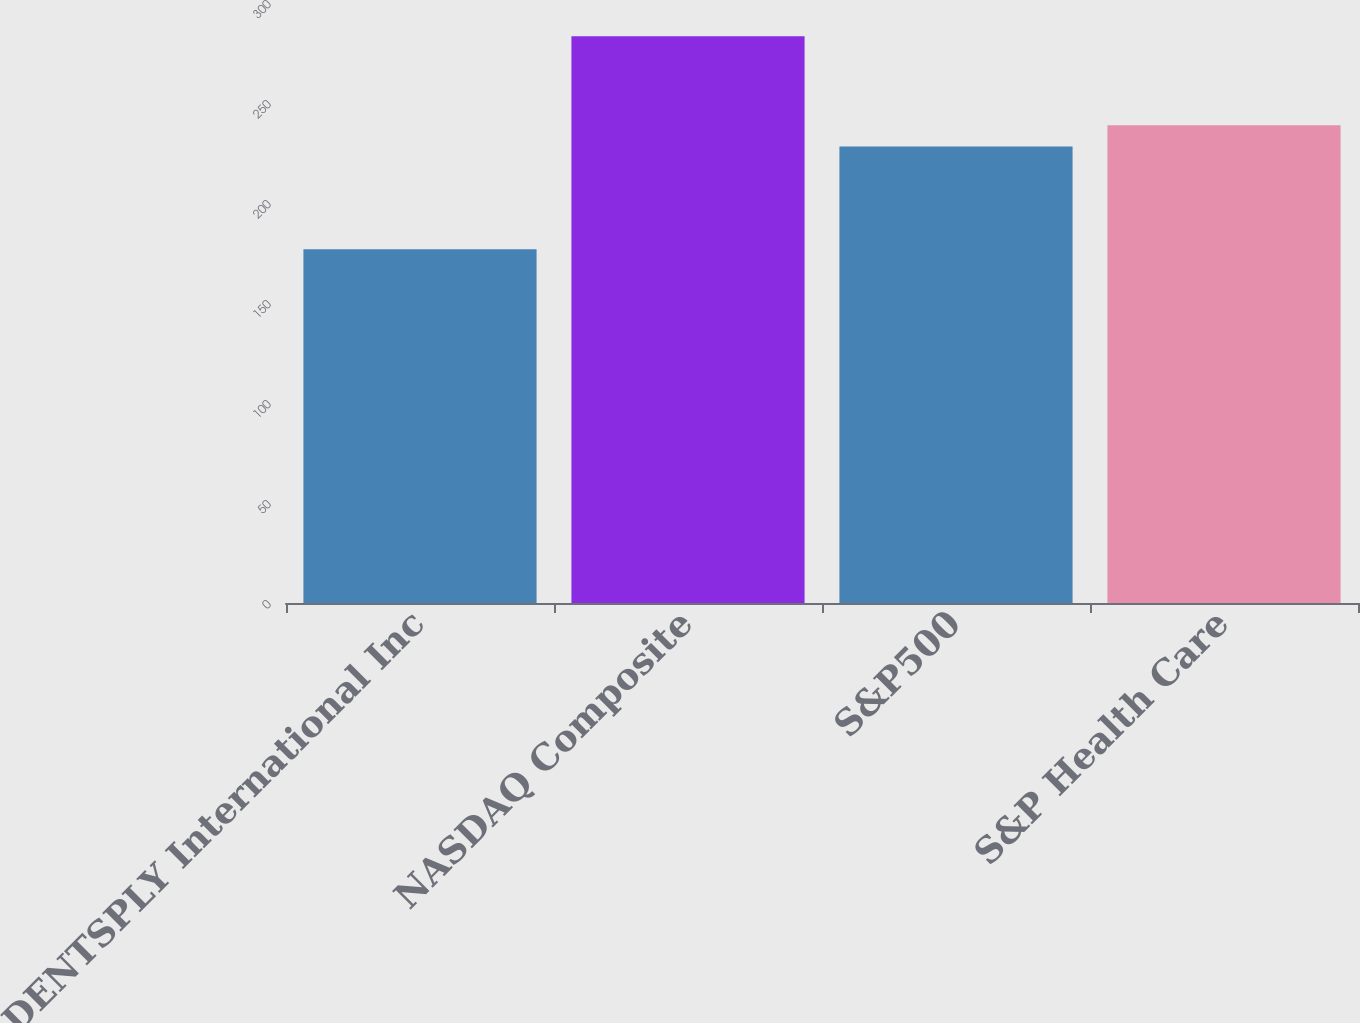Convert chart. <chart><loc_0><loc_0><loc_500><loc_500><bar_chart><fcel>DENTSPLY International Inc<fcel>NASDAQ Composite<fcel>S&P500<fcel>S&P Health Care<nl><fcel>176.89<fcel>283.39<fcel>228.19<fcel>238.84<nl></chart> 